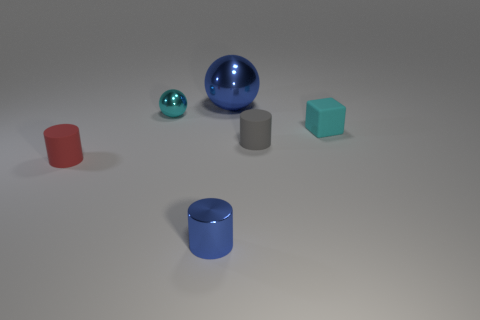Add 1 red things. How many objects exist? 7 Subtract all matte cylinders. How many cylinders are left? 1 Subtract all blocks. How many objects are left? 5 Subtract 1 blocks. How many blocks are left? 0 Subtract all small gray things. Subtract all large yellow metal cylinders. How many objects are left? 5 Add 1 red rubber things. How many red rubber things are left? 2 Add 4 tiny cubes. How many tiny cubes exist? 5 Subtract all cyan balls. How many balls are left? 1 Subtract 0 brown balls. How many objects are left? 6 Subtract all purple blocks. Subtract all blue cylinders. How many blocks are left? 1 